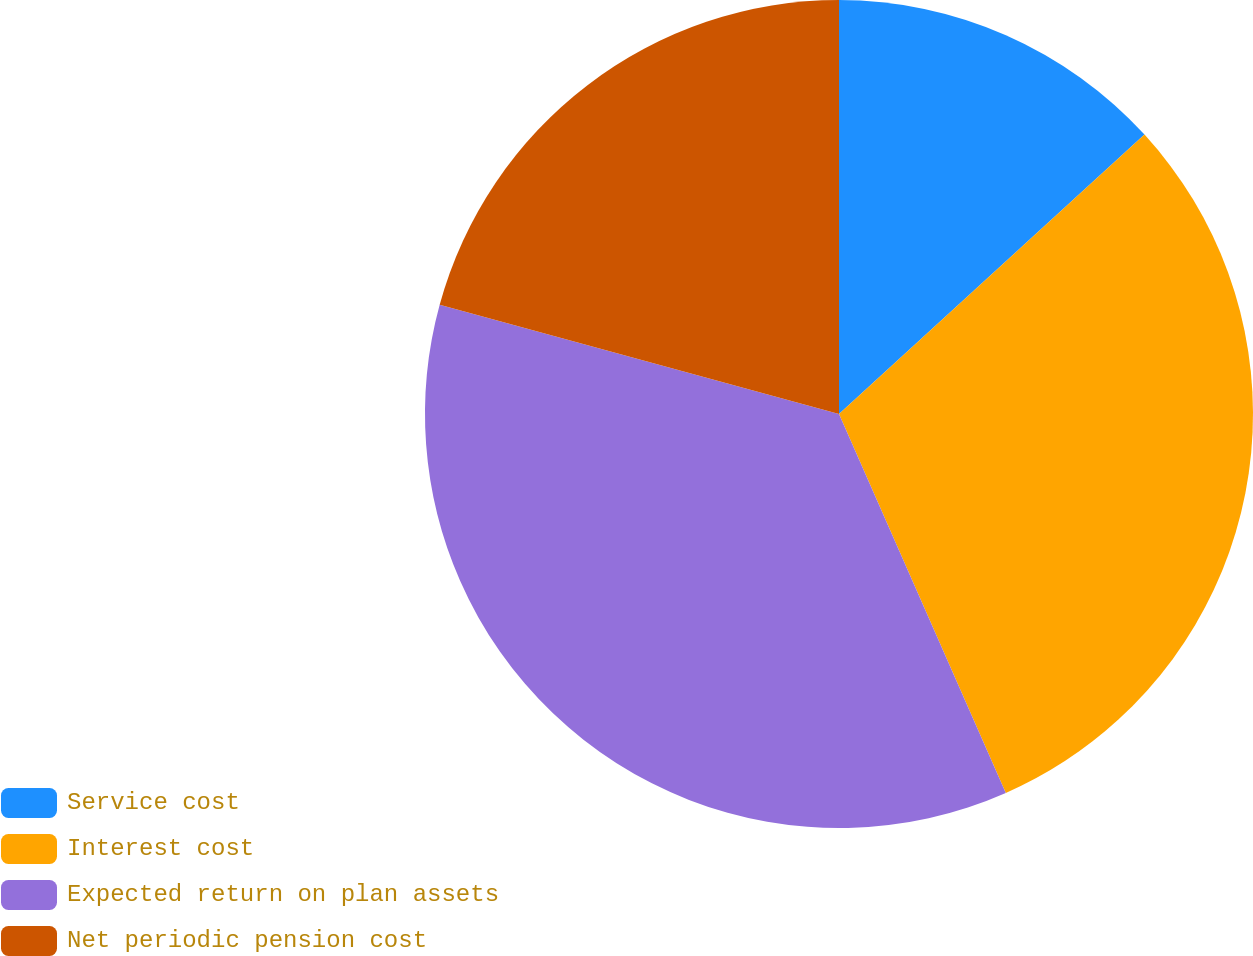<chart> <loc_0><loc_0><loc_500><loc_500><pie_chart><fcel>Service cost<fcel>Interest cost<fcel>Expected return on plan assets<fcel>Net periodic pension cost<nl><fcel>13.21%<fcel>30.19%<fcel>35.85%<fcel>20.75%<nl></chart> 